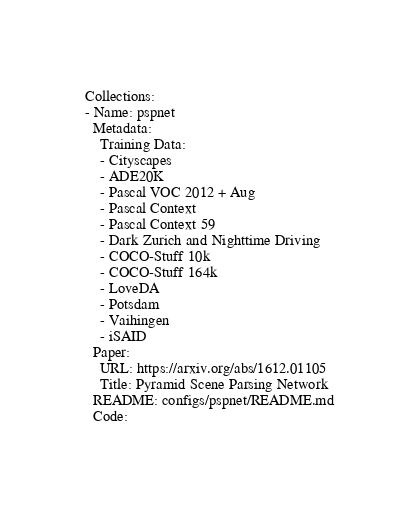Convert code to text. <code><loc_0><loc_0><loc_500><loc_500><_YAML_>Collections:
- Name: pspnet
  Metadata:
    Training Data:
    - Cityscapes
    - ADE20K
    - Pascal VOC 2012 + Aug
    - Pascal Context
    - Pascal Context 59
    - Dark Zurich and Nighttime Driving
    - COCO-Stuff 10k
    - COCO-Stuff 164k
    - LoveDA
    - Potsdam
    - Vaihingen
    - iSAID
  Paper:
    URL: https://arxiv.org/abs/1612.01105
    Title: Pyramid Scene Parsing Network
  README: configs/pspnet/README.md
  Code:</code> 